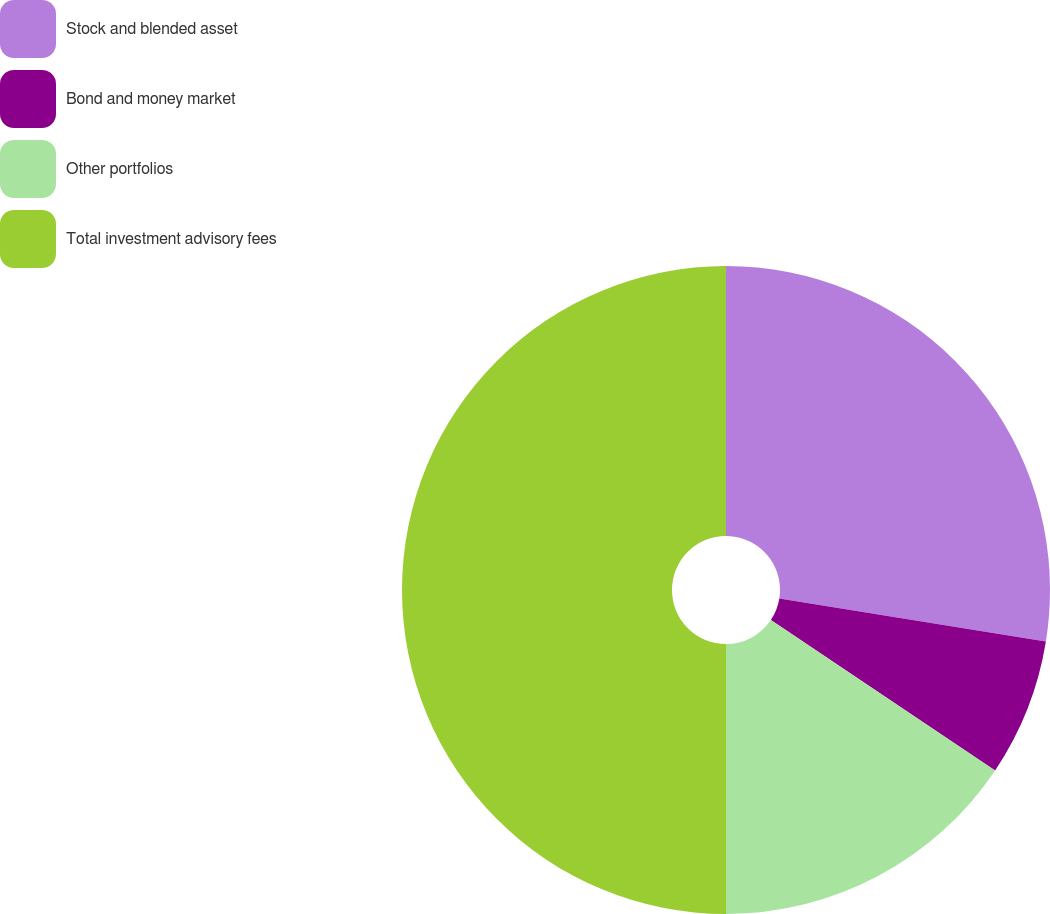Convert chart. <chart><loc_0><loc_0><loc_500><loc_500><pie_chart><fcel>Stock and blended asset<fcel>Bond and money market<fcel>Other portfolios<fcel>Total investment advisory fees<nl><fcel>27.54%<fcel>6.86%<fcel>15.6%<fcel>50.0%<nl></chart> 